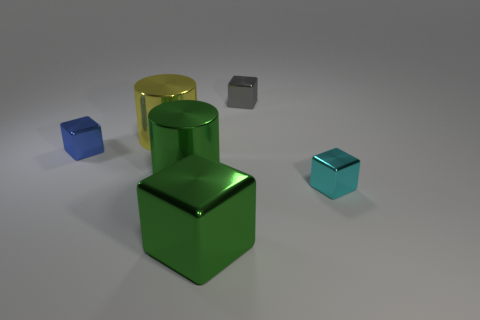What is the large yellow thing made of?
Your answer should be compact. Metal. Are there the same number of tiny gray things that are in front of the gray block and blocks?
Give a very brief answer. No. What number of green shiny objects are the same shape as the small gray thing?
Your answer should be compact. 1. Does the blue metal object have the same shape as the gray thing?
Your response must be concise. Yes. How many things are either green metallic things in front of the gray cube or cyan shiny objects?
Give a very brief answer. 3. What is the shape of the large thing to the right of the big cylinder that is in front of the tiny thing that is to the left of the green block?
Ensure brevity in your answer.  Cube. There is a big yellow thing that is the same material as the blue object; what shape is it?
Provide a short and direct response. Cylinder. How big is the blue metallic object?
Offer a terse response. Small. Is the cyan cube the same size as the green block?
Your answer should be compact. No. What number of things are either metal cubes left of the tiny gray metal block or tiny cubes that are left of the gray object?
Keep it short and to the point. 2. 